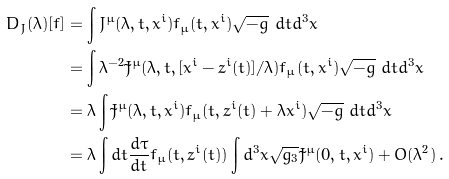<formula> <loc_0><loc_0><loc_500><loc_500>D _ { J } ( \lambda ) [ f ] & = \int J ^ { \mu } ( \lambda , t , x ^ { i } ) f _ { \mu } ( t , x ^ { i } ) \sqrt { - g } \ d t d ^ { 3 } x \\ & = \int \lambda ^ { - 2 } \tilde { J } ^ { \mu } ( \lambda , t , [ x ^ { i } - z ^ { i } ( t ) ] / \lambda ) f _ { \mu } ( t , x ^ { i } ) \sqrt { - g } \ d t d ^ { 3 } x \\ & = \lambda \int \tilde { J } ^ { \mu } ( \lambda , t , \bar { x } ^ { i } ) f _ { \mu } ( t , z ^ { i } ( t ) + \lambda \bar { x } ^ { i } ) \sqrt { - g } \ d t d ^ { 3 } \bar { x } \\ & = \lambda \int d t \frac { d \tau } { d t } f _ { \mu } ( t , z ^ { i } ( t ) ) \int d ^ { 3 } \bar { x } \sqrt { g _ { 3 } } \tilde { J } ^ { \mu } ( 0 , t , \bar { x } ^ { i } ) + O ( \lambda ^ { 2 } ) \, .</formula> 